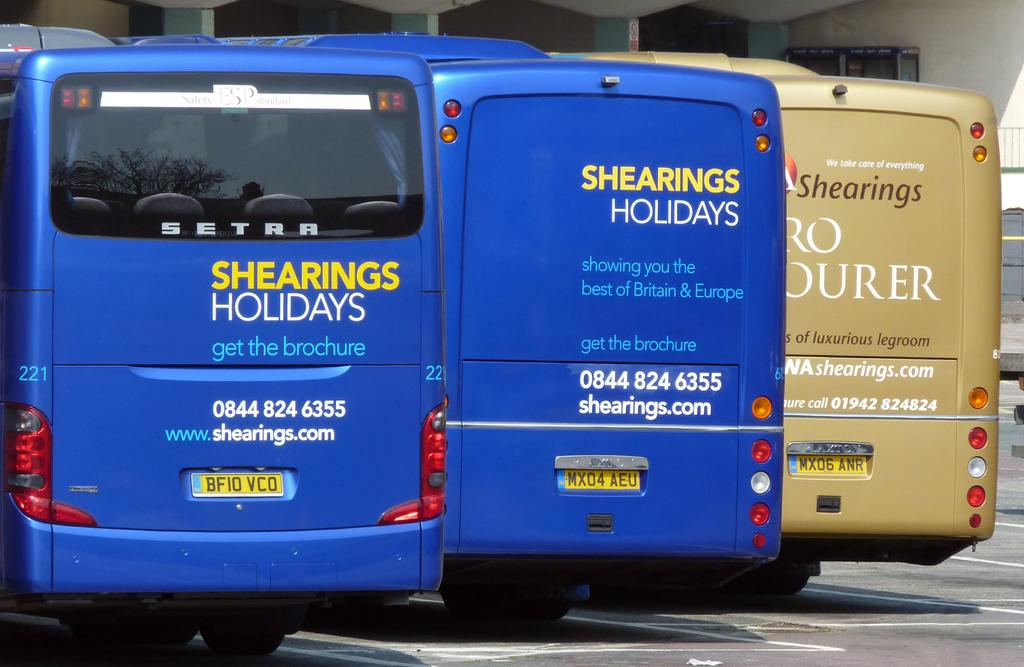How many buses can be seen in the image? There are three buses in the image. What is the status of the buses in the image? The buses are parked. What can be seen in the background of the image? There is a wall in the background of the image. What identifiers are present on the buses? Number plates are visible on the buses. What features are present on the buses that might be used for illumination? Lights are present on the buses. Can you identify any other objects in the image besides the buses? Yes, there is a glass in the image. What type of crow is perched on the bus in the image? There is no crow present in the image; it only features buses, a wall, and a glass. 